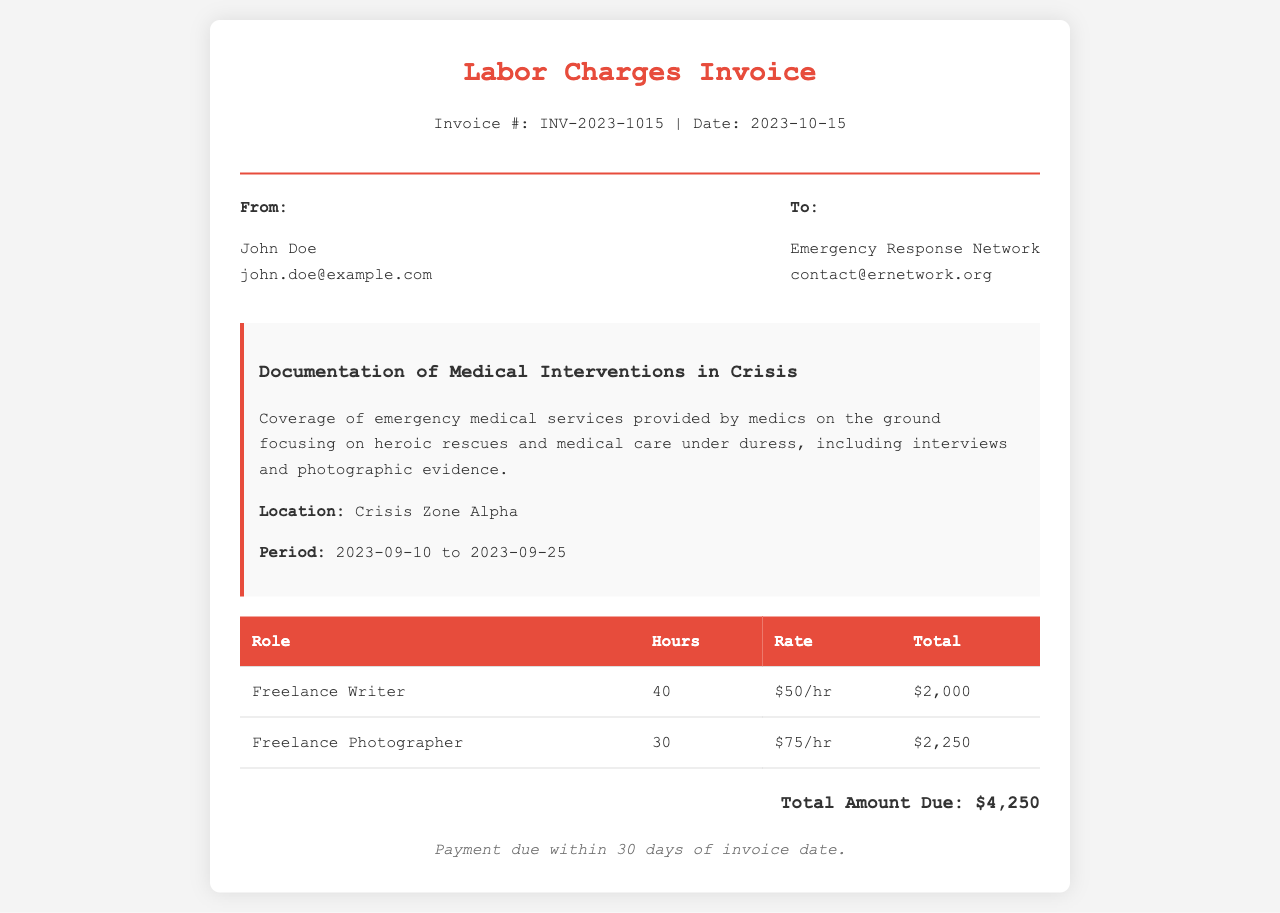What is the invoice number? The invoice number is listed in the document header under the title of the invoice.
Answer: INV-2023-1015 What is the total amount due? The total amount due is stated at the bottom of the invoice after the itemized costs.
Answer: $4,250 Who is the freelance writer? The name of the freelance writer is mentioned in the "From" section of the document.
Answer: John Doe What is the hourly rate for the freelance photographer? The hourly rate for the freelance photographer can be found in the table under the rate column.
Answer: $75/hr What period does the project cover? The project period is explicitly stated in the project description section of the document.
Answer: 2023-09-10 to 2023-09-25 How many hours did the freelance writer work? The hours worked are detailed in the table under the "Hours" column for the freelance writer.
Answer: 40 What is the purpose of this invoice? The purpose is provided in the project description section of the invoice explaining its focus.
Answer: Documentation of Medical Interventions in Crisis When is the payment due? The payment terms are provided at the bottom of the invoice indicating the payment deadline.
Answer: Within 30 days of invoice date 